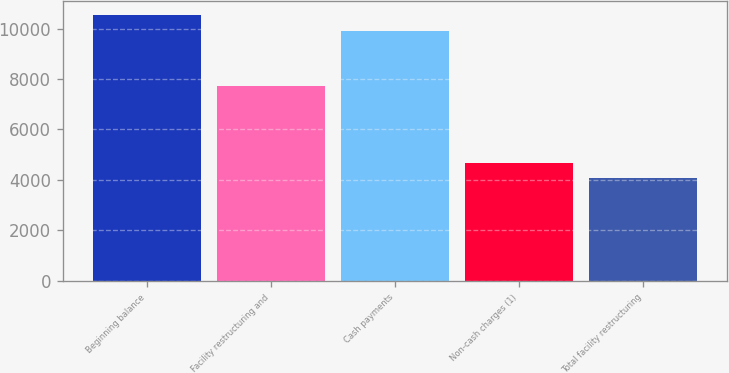Convert chart to OTSL. <chart><loc_0><loc_0><loc_500><loc_500><bar_chart><fcel>Beginning balance<fcel>Facility restructuring and<fcel>Cash payments<fcel>Non-cash charges (1)<fcel>Total facility restructuring<nl><fcel>10551<fcel>7706<fcel>9920<fcel>4692<fcel>4061<nl></chart> 